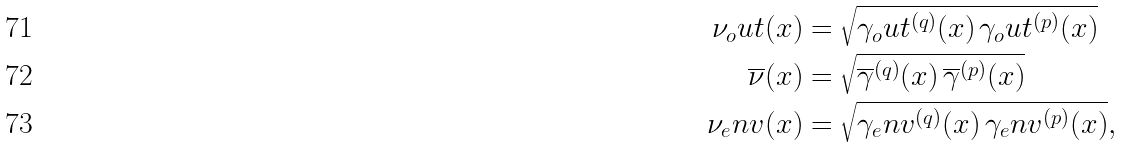Convert formula to latex. <formula><loc_0><loc_0><loc_500><loc_500>\nu _ { o } u t ( x ) & = \sqrt { \gamma _ { o } u t ^ { ( q ) } ( x ) \, \gamma _ { o } u t ^ { ( p ) } ( x ) } \\ \overline { \nu } ( x ) & = \sqrt { \overline { \gamma } ^ { ( q ) } ( x ) \, \overline { \gamma } ^ { ( p ) } ( x ) } \\ \nu _ { e } n v ( x ) & = \sqrt { \gamma _ { e } n v ^ { ( q ) } ( x ) \, \gamma _ { e } n v ^ { ( p ) } ( x ) } ,</formula> 